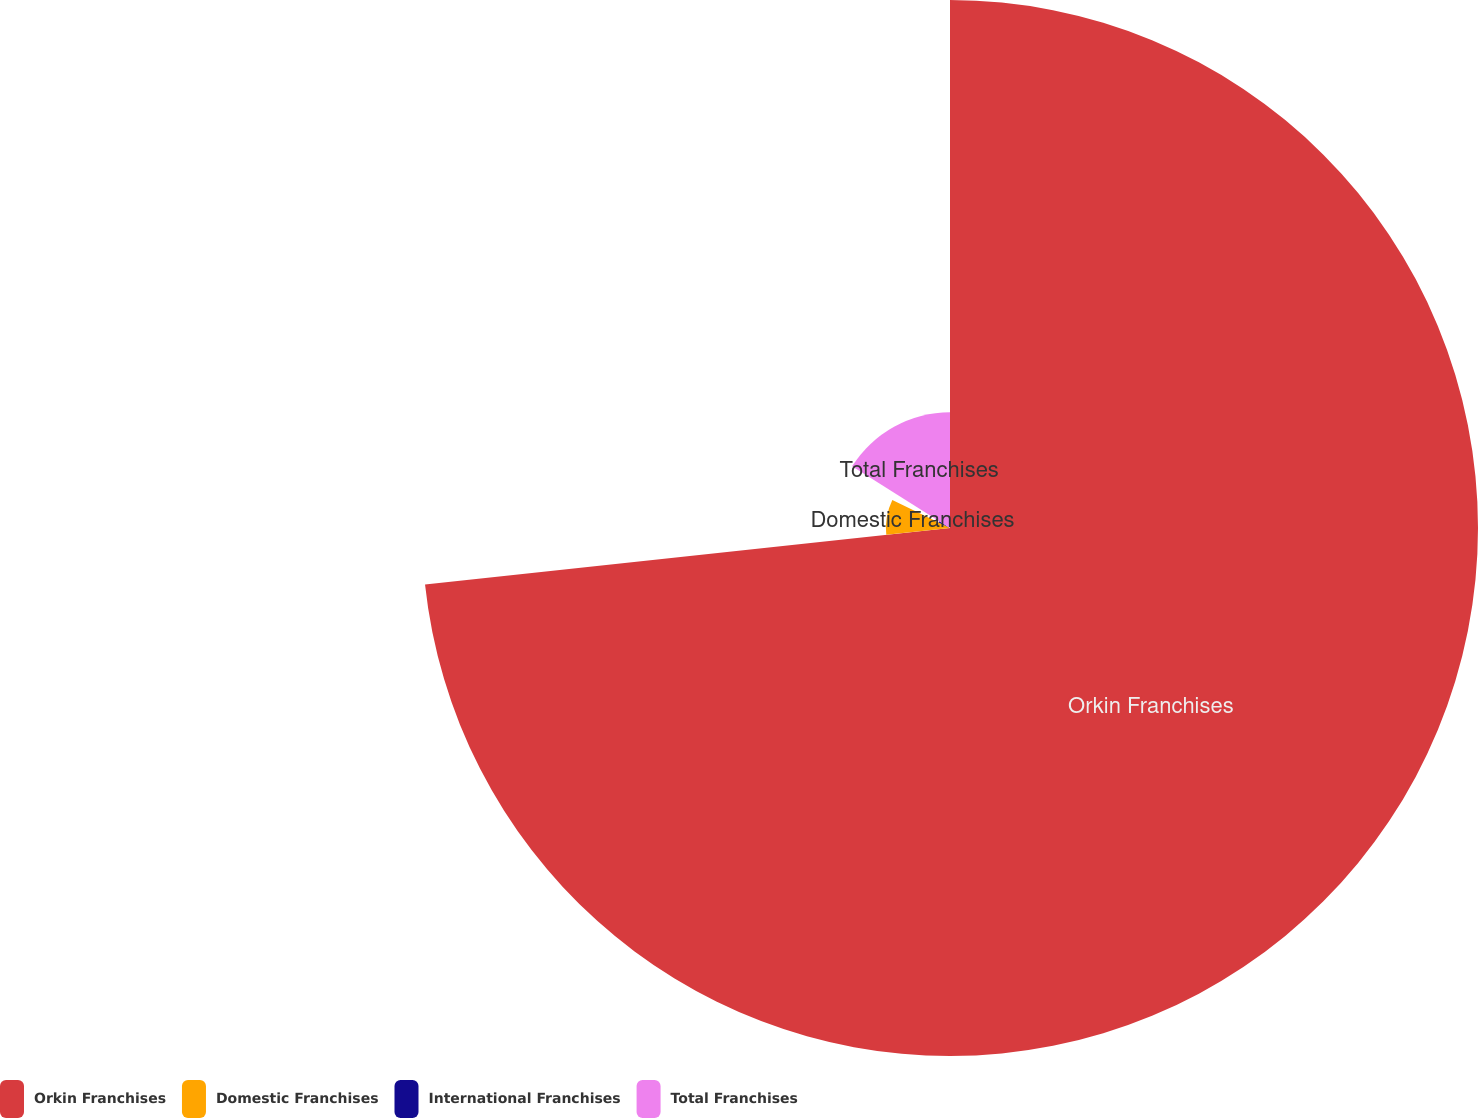<chart> <loc_0><loc_0><loc_500><loc_500><pie_chart><fcel>Orkin Franchises<fcel>Domestic Franchises<fcel>International Franchises<fcel>Total Franchises<nl><fcel>73.3%<fcel>8.9%<fcel>1.75%<fcel>16.06%<nl></chart> 